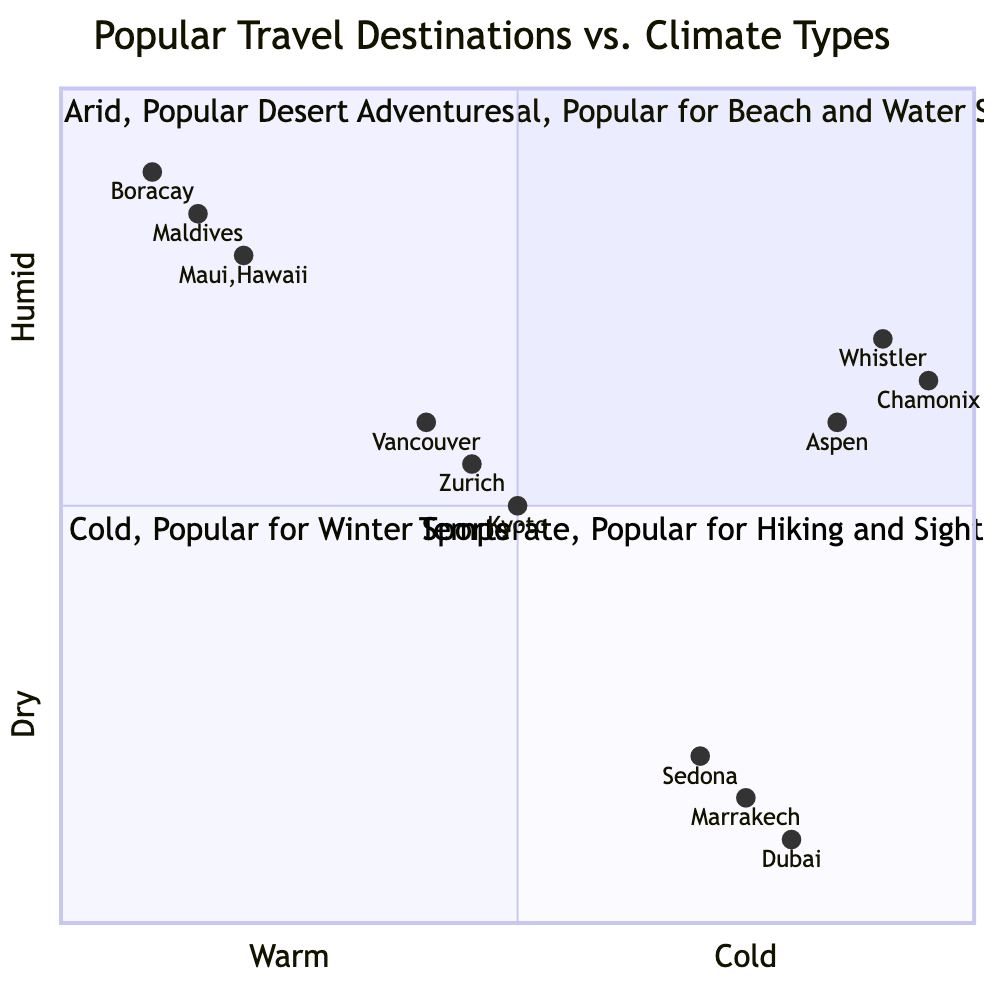What destinations are categorized as Tropical? The Tropical quadrant lists Maui, Hawaii; Boracay, Philippines; and Maldives as popular destinations.
Answer: Maui, Hawaii; Boracay, Philippines; Maldives Which destination is popular for desert adventures? The Arid quadrant includes Dubai, UAE, Sedona, Arizona, and Marrakech, Morocco as popular for desert activities.
Answer: Dubai, UAE How many destinations are found in the Cold quadrant? The Cold quadrant has three listed destinations: Whistler, Canada; Chamonix, France; and Aspen, Colorado.
Answer: 3 What activities can you do in Kyoto, Japan? In the Temperate quadrant, Kyoto offers Temple Visits, Cherry Blossom Viewing, and History Tours.
Answer: Temple Visits, Cherry Blossom Viewing, History Tours Which destination is located closest to the cold end of the spectrum? Within the Cold quadrant, Chamonix, France has coordinates ([0.95, 0.65]), placing it nearest to the cold extreme compared to others in the Cold quadrant.
Answer: Chamonix, France How many destinations are categorized as Tropical or Arid? The Tropical quadrant has three destinations (Maui, Boracay, Maldives), and the Arid quadrant has three as well (Dubai, Sedona, Marrakech), totaling six destinations.
Answer: 6 What is the primary activity for destinations in the Cold quadrant? The common activities in the Cold quadrant primarily focus on winter sports, highlighting skiing, snowboarding, and snowmobiling.
Answer: Winter sports Which Temperate destination is most popular for hiking and cycling? Vancouver, Canada clearly stands out in the Temperate quadrant for its hiking and cycling opportunities, identified directly from the destination list.
Answer: Vancouver, Canada 